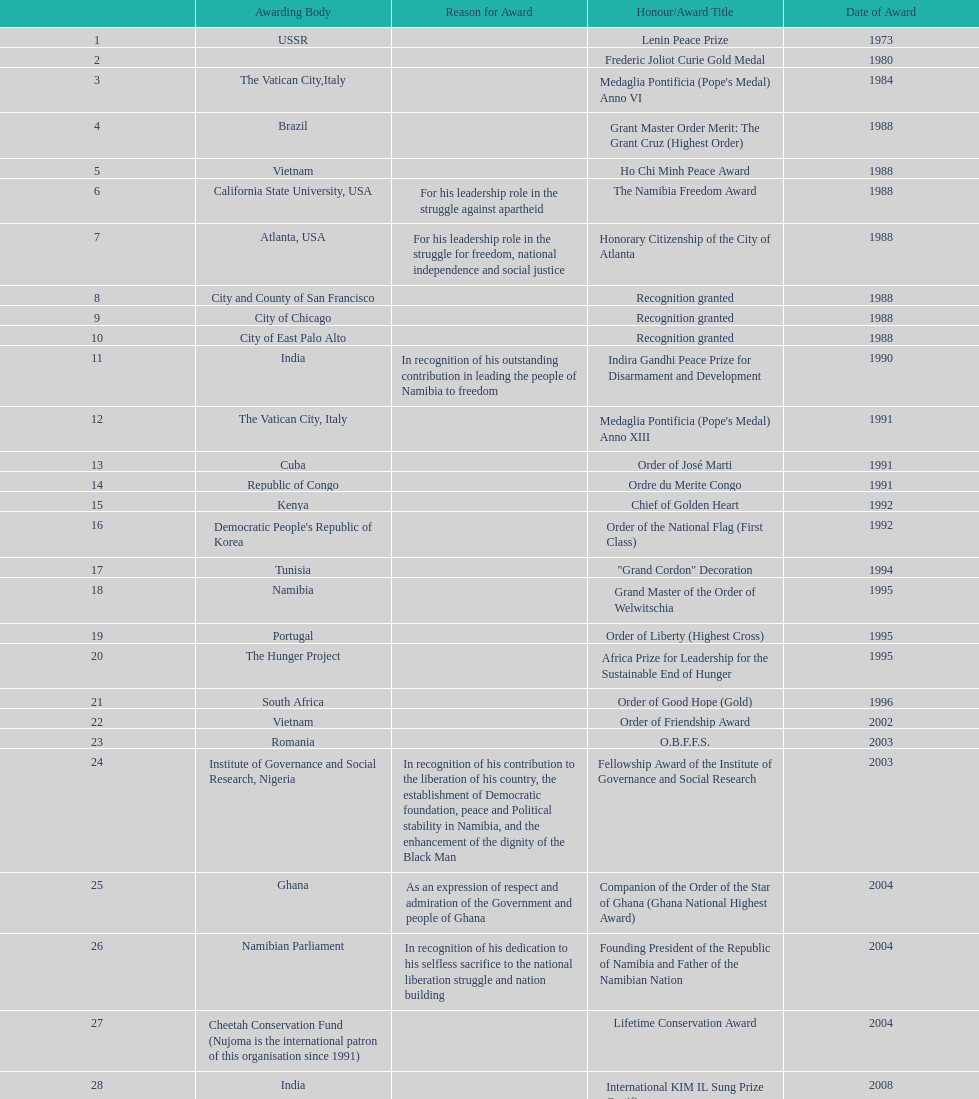What is the total number of awards that nujoma won? 29. 